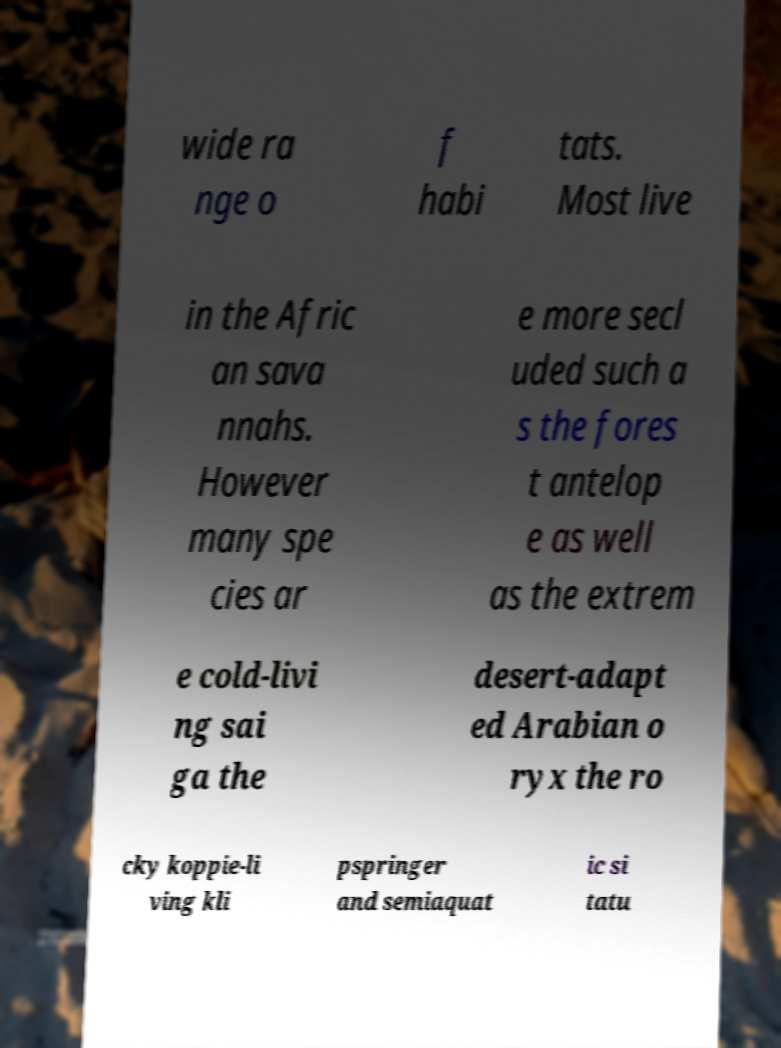For documentation purposes, I need the text within this image transcribed. Could you provide that? wide ra nge o f habi tats. Most live in the Afric an sava nnahs. However many spe cies ar e more secl uded such a s the fores t antelop e as well as the extrem e cold-livi ng sai ga the desert-adapt ed Arabian o ryx the ro cky koppie-li ving kli pspringer and semiaquat ic si tatu 